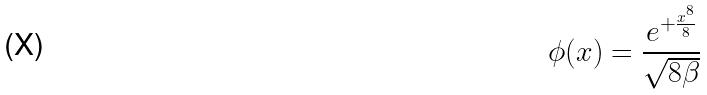<formula> <loc_0><loc_0><loc_500><loc_500>\phi ( x ) = \frac { e ^ { + \frac { x ^ { 8 } } { 8 } } } { \sqrt { 8 \beta } }</formula> 